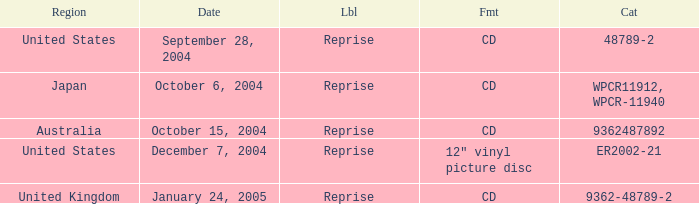Name the label for january 24, 2005 Reprise. 